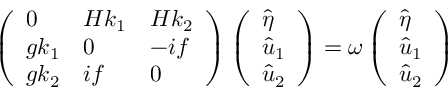<formula> <loc_0><loc_0><loc_500><loc_500>\left ( \begin{array} { l l l } { 0 } & { H k _ { 1 } } & { H k _ { 2 } } \\ { g k _ { 1 } } & { 0 } & { - i f } \\ { g k _ { 2 } } & { i f } & { 0 } \end{array} \right ) \left ( \begin{array} { l } { \hat { \eta } } \\ { \hat { u } _ { 1 } } \\ { \hat { u } _ { 2 } } \end{array} \right ) = \omega \left ( \begin{array} { l } { \hat { \eta } } \\ { \hat { u } _ { 1 } } \\ { \hat { u } _ { 2 } } \end{array} \right )</formula> 